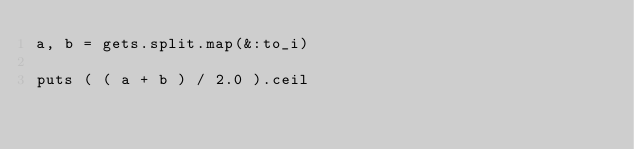Convert code to text. <code><loc_0><loc_0><loc_500><loc_500><_Ruby_>a, b = gets.split.map(&:to_i)

puts ( ( a + b ) / 2.0 ).ceil</code> 